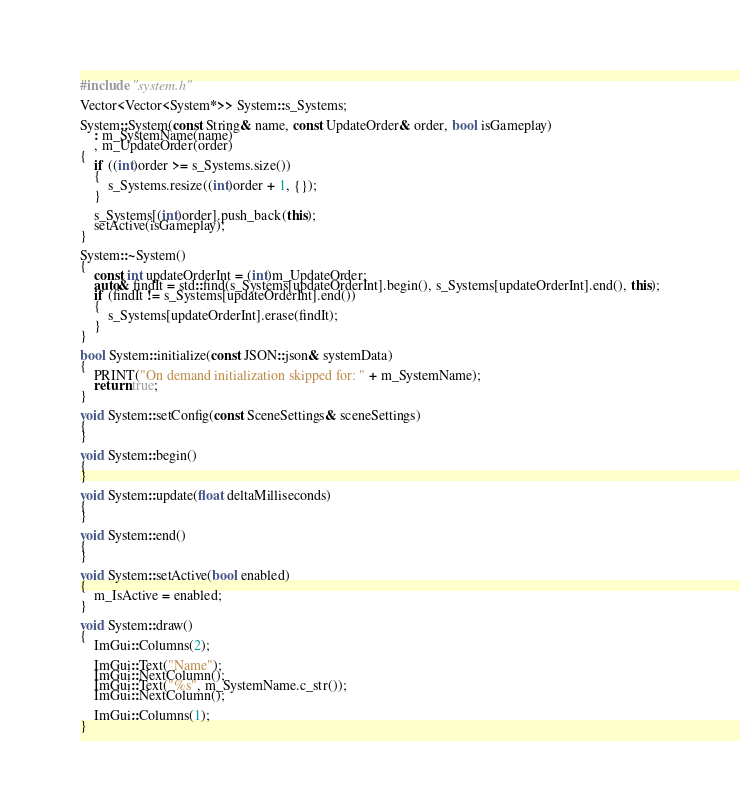<code> <loc_0><loc_0><loc_500><loc_500><_C++_>#include "system.h"

Vector<Vector<System*>> System::s_Systems;

System::System(const String& name, const UpdateOrder& order, bool isGameplay)
    : m_SystemName(name)
    , m_UpdateOrder(order)
{
	if ((int)order >= s_Systems.size())
	{
		s_Systems.resize((int)order + 1, {});
	}

	s_Systems[(int)order].push_back(this);
	setActive(isGameplay);
}

System::~System()
{
	const int updateOrderInt = (int)m_UpdateOrder;
	auto& findIt = std::find(s_Systems[updateOrderInt].begin(), s_Systems[updateOrderInt].end(), this);
	if (findIt != s_Systems[updateOrderInt].end())
	{
		s_Systems[updateOrderInt].erase(findIt);
	}
}

bool System::initialize(const JSON::json& systemData)
{
	PRINT("On demand initialization skipped for: " + m_SystemName);
	return true;
}

void System::setConfig(const SceneSettings& sceneSettings)
{
}

void System::begin()
{
}

void System::update(float deltaMilliseconds)
{
}

void System::end()
{
}

void System::setActive(bool enabled)
{
	m_IsActive = enabled;
}

void System::draw()
{
	ImGui::Columns(2);

	ImGui::Text("Name");
	ImGui::NextColumn();
	ImGui::Text("%s", m_SystemName.c_str());
	ImGui::NextColumn();

	ImGui::Columns(1);
}
</code> 